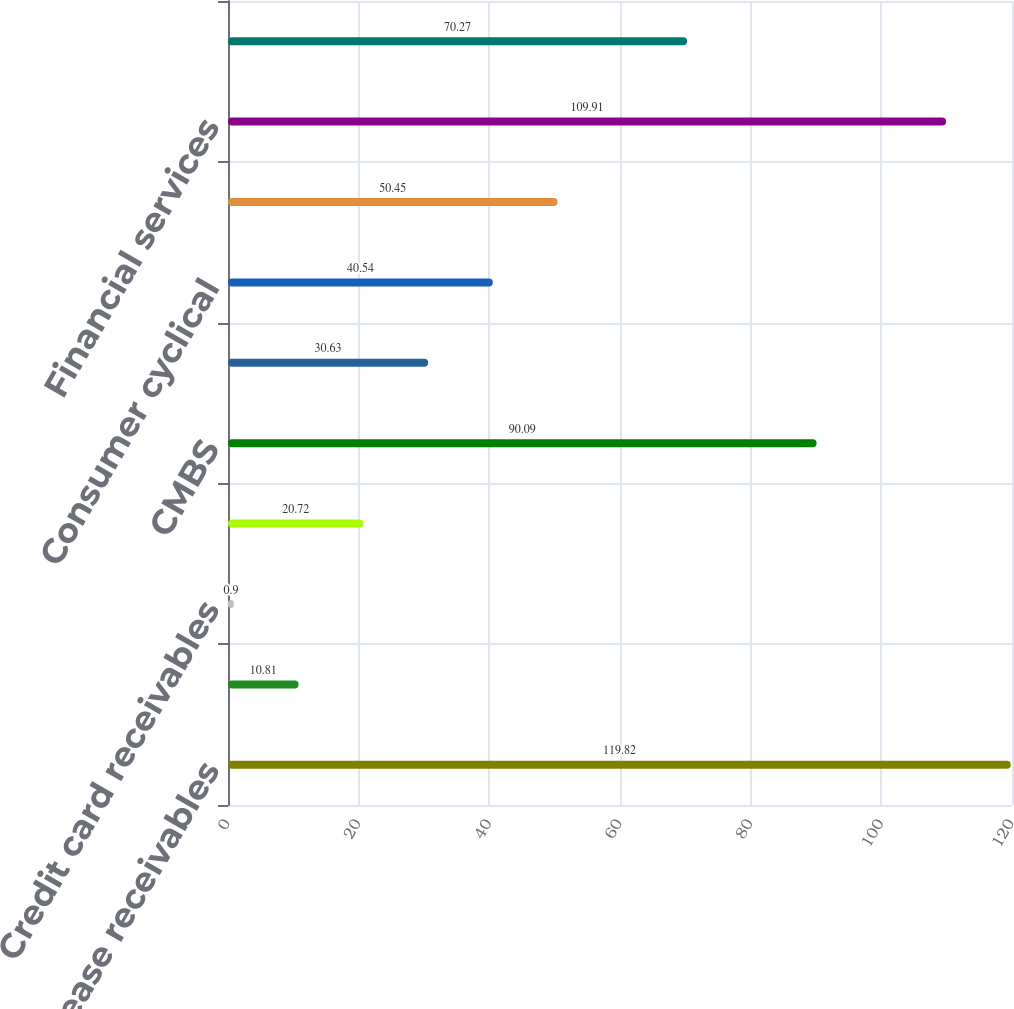Convert chart. <chart><loc_0><loc_0><loc_500><loc_500><bar_chart><fcel>Aircraft lease receivables<fcel>CDOs<fcel>Credit card receivables<fcel>Other ABS<fcel>CMBS<fcel>Basic industry<fcel>Consumer cyclical<fcel>Consumer non-cyclical<fcel>Financial services<fcel>Technology and communications<nl><fcel>119.82<fcel>10.81<fcel>0.9<fcel>20.72<fcel>90.09<fcel>30.63<fcel>40.54<fcel>50.45<fcel>109.91<fcel>70.27<nl></chart> 